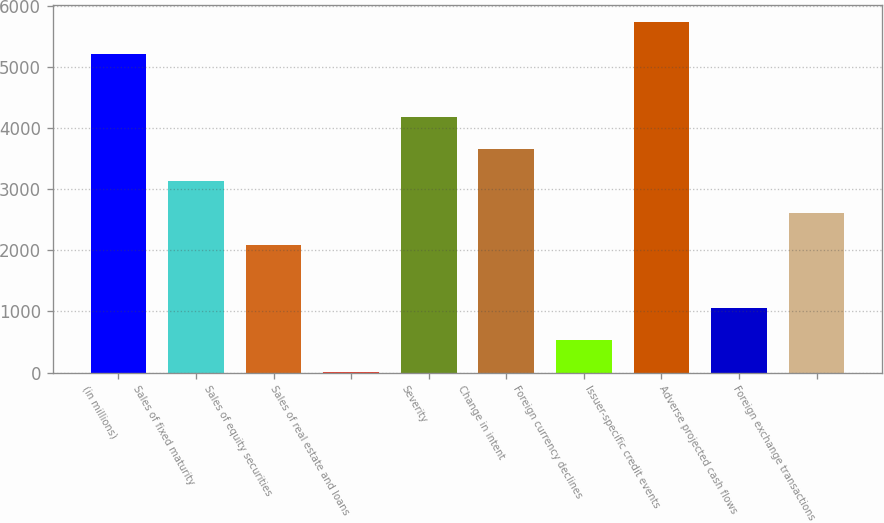Convert chart to OTSL. <chart><loc_0><loc_0><loc_500><loc_500><bar_chart><fcel>(in millions)<fcel>Sales of fixed maturity<fcel>Sales of equity securities<fcel>Sales of real estate and loans<fcel>Severity<fcel>Change in intent<fcel>Foreign currency declines<fcel>Issuer-specific credit events<fcel>Adverse projected cash flows<fcel>Foreign exchange transactions<nl><fcel>5210<fcel>3133.2<fcel>2094.8<fcel>18<fcel>4171.6<fcel>3652.4<fcel>537.2<fcel>5729.2<fcel>1056.4<fcel>2614<nl></chart> 